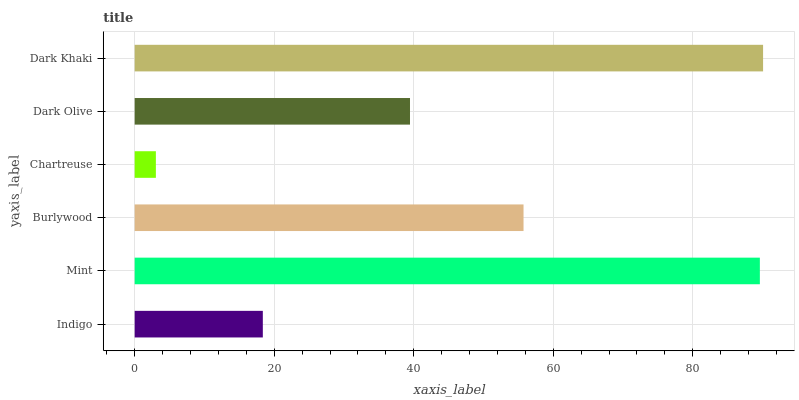Is Chartreuse the minimum?
Answer yes or no. Yes. Is Dark Khaki the maximum?
Answer yes or no. Yes. Is Mint the minimum?
Answer yes or no. No. Is Mint the maximum?
Answer yes or no. No. Is Mint greater than Indigo?
Answer yes or no. Yes. Is Indigo less than Mint?
Answer yes or no. Yes. Is Indigo greater than Mint?
Answer yes or no. No. Is Mint less than Indigo?
Answer yes or no. No. Is Burlywood the high median?
Answer yes or no. Yes. Is Dark Olive the low median?
Answer yes or no. Yes. Is Mint the high median?
Answer yes or no. No. Is Mint the low median?
Answer yes or no. No. 